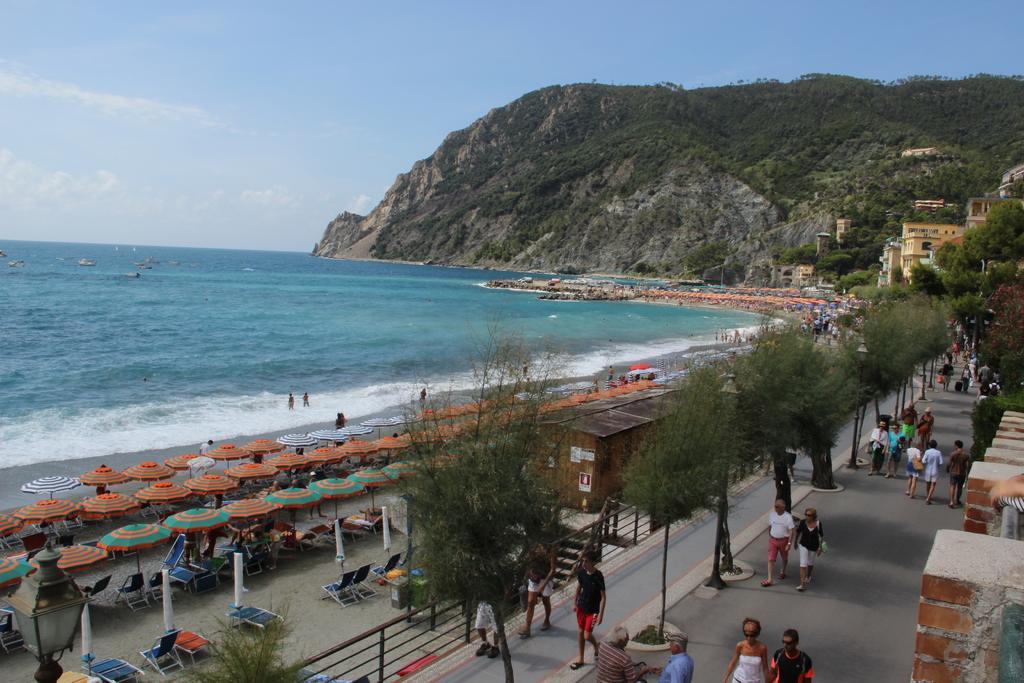In one or two sentences, can you explain what this image depicts? On the right side of the image we can see trees, buildings, persons, road. On the left side of the image there is ocean, ships, shacks, chairs and shed. In the background there is hill, sky and clouds. 